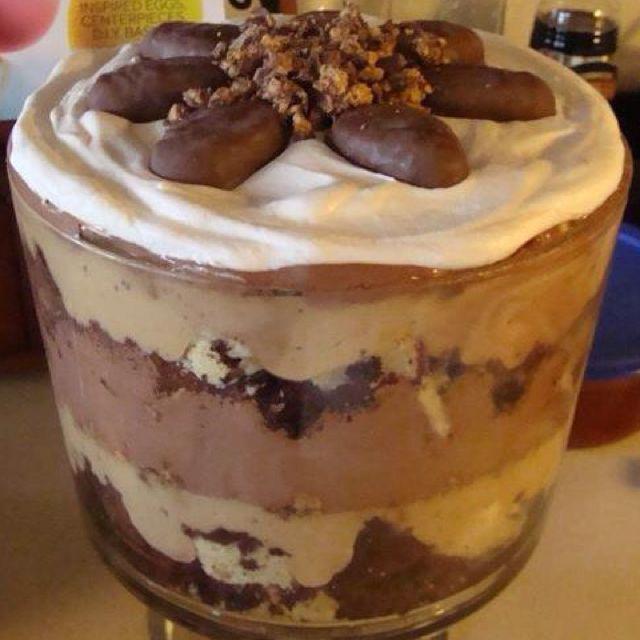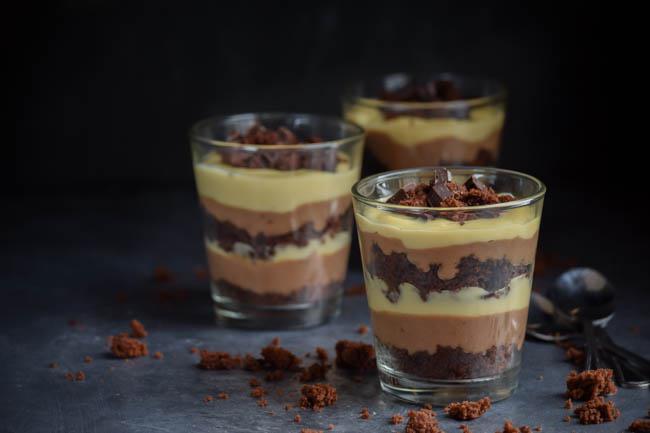The first image is the image on the left, the second image is the image on the right. For the images shown, is this caption "An image shows at least four individual layered desserts served in slender cylindrical glasses." true? Answer yes or no. No. 